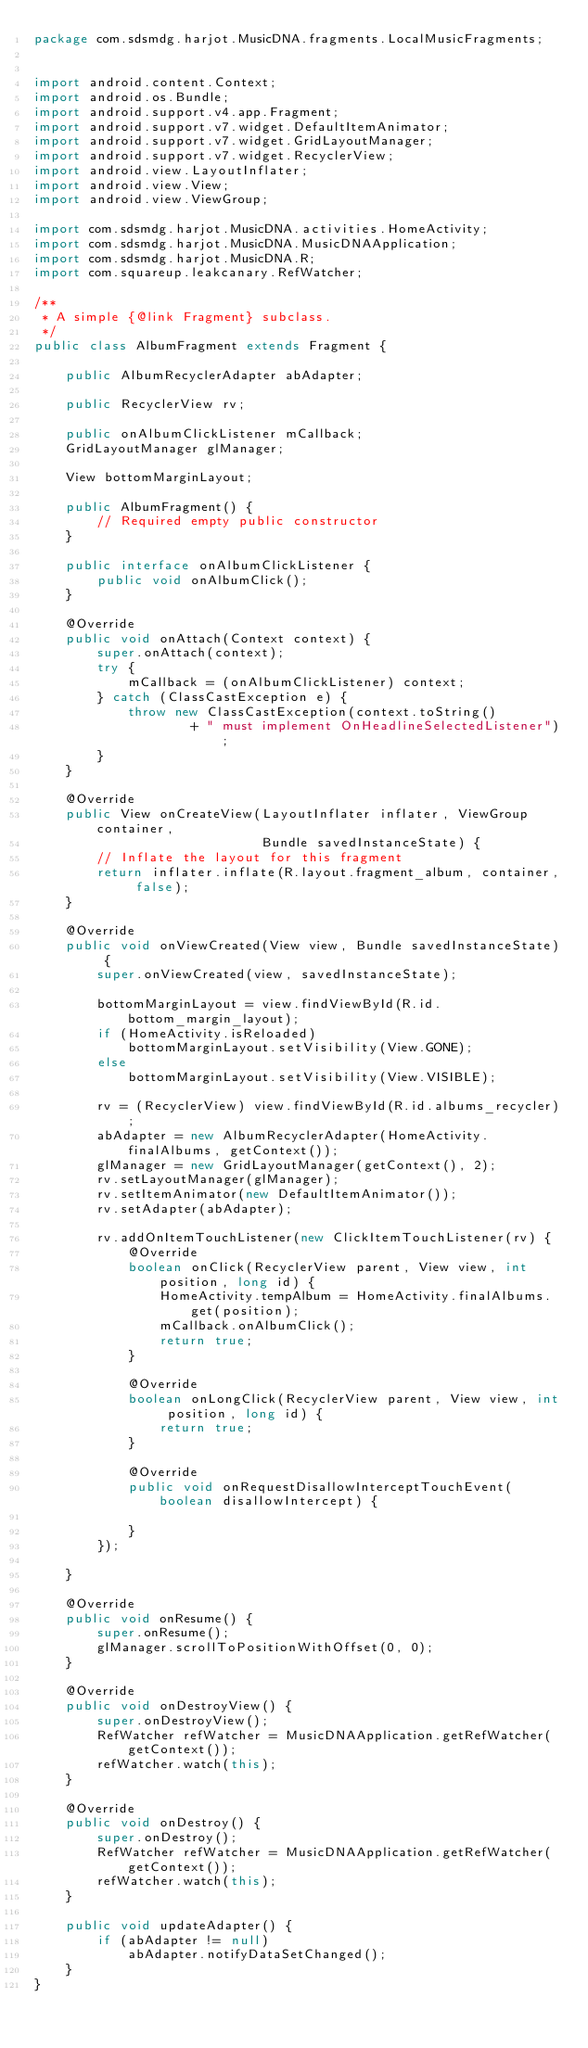Convert code to text. <code><loc_0><loc_0><loc_500><loc_500><_Java_>package com.sdsmdg.harjot.MusicDNA.fragments.LocalMusicFragments;


import android.content.Context;
import android.os.Bundle;
import android.support.v4.app.Fragment;
import android.support.v7.widget.DefaultItemAnimator;
import android.support.v7.widget.GridLayoutManager;
import android.support.v7.widget.RecyclerView;
import android.view.LayoutInflater;
import android.view.View;
import android.view.ViewGroup;

import com.sdsmdg.harjot.MusicDNA.activities.HomeActivity;
import com.sdsmdg.harjot.MusicDNA.MusicDNAApplication;
import com.sdsmdg.harjot.MusicDNA.R;
import com.squareup.leakcanary.RefWatcher;

/**
 * A simple {@link Fragment} subclass.
 */
public class AlbumFragment extends Fragment {

    public AlbumRecyclerAdapter abAdapter;

    public RecyclerView rv;

    public onAlbumClickListener mCallback;
    GridLayoutManager glManager;

    View bottomMarginLayout;

    public AlbumFragment() {
        // Required empty public constructor
    }

    public interface onAlbumClickListener {
        public void onAlbumClick();
    }

    @Override
    public void onAttach(Context context) {
        super.onAttach(context);
        try {
            mCallback = (onAlbumClickListener) context;
        } catch (ClassCastException e) {
            throw new ClassCastException(context.toString()
                    + " must implement OnHeadlineSelectedListener");
        }
    }

    @Override
    public View onCreateView(LayoutInflater inflater, ViewGroup container,
                             Bundle savedInstanceState) {
        // Inflate the layout for this fragment
        return inflater.inflate(R.layout.fragment_album, container, false);
    }

    @Override
    public void onViewCreated(View view, Bundle savedInstanceState) {
        super.onViewCreated(view, savedInstanceState);

        bottomMarginLayout = view.findViewById(R.id.bottom_margin_layout);
        if (HomeActivity.isReloaded)
            bottomMarginLayout.setVisibility(View.GONE);
        else
            bottomMarginLayout.setVisibility(View.VISIBLE);

        rv = (RecyclerView) view.findViewById(R.id.albums_recycler);
        abAdapter = new AlbumRecyclerAdapter(HomeActivity.finalAlbums, getContext());
        glManager = new GridLayoutManager(getContext(), 2);
        rv.setLayoutManager(glManager);
        rv.setItemAnimator(new DefaultItemAnimator());
        rv.setAdapter(abAdapter);

        rv.addOnItemTouchListener(new ClickItemTouchListener(rv) {
            @Override
            boolean onClick(RecyclerView parent, View view, int position, long id) {
                HomeActivity.tempAlbum = HomeActivity.finalAlbums.get(position);
                mCallback.onAlbumClick();
                return true;
            }

            @Override
            boolean onLongClick(RecyclerView parent, View view, int position, long id) {
                return true;
            }

            @Override
            public void onRequestDisallowInterceptTouchEvent(boolean disallowIntercept) {

            }
        });

    }

    @Override
    public void onResume() {
        super.onResume();
        glManager.scrollToPositionWithOffset(0, 0);
    }

    @Override
    public void onDestroyView() {
        super.onDestroyView();
        RefWatcher refWatcher = MusicDNAApplication.getRefWatcher(getContext());
        refWatcher.watch(this);
    }

    @Override
    public void onDestroy() {
        super.onDestroy();
        RefWatcher refWatcher = MusicDNAApplication.getRefWatcher(getContext());
        refWatcher.watch(this);
    }

    public void updateAdapter() {
        if (abAdapter != null)
            abAdapter.notifyDataSetChanged();
    }
}
</code> 